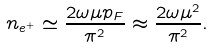Convert formula to latex. <formula><loc_0><loc_0><loc_500><loc_500>n _ { e ^ { + } } \simeq \frac { 2 \omega \mu p _ { F } } { \pi ^ { 2 } } \approx \frac { 2 \omega \mu ^ { 2 } } { \pi ^ { 2 } } .</formula> 